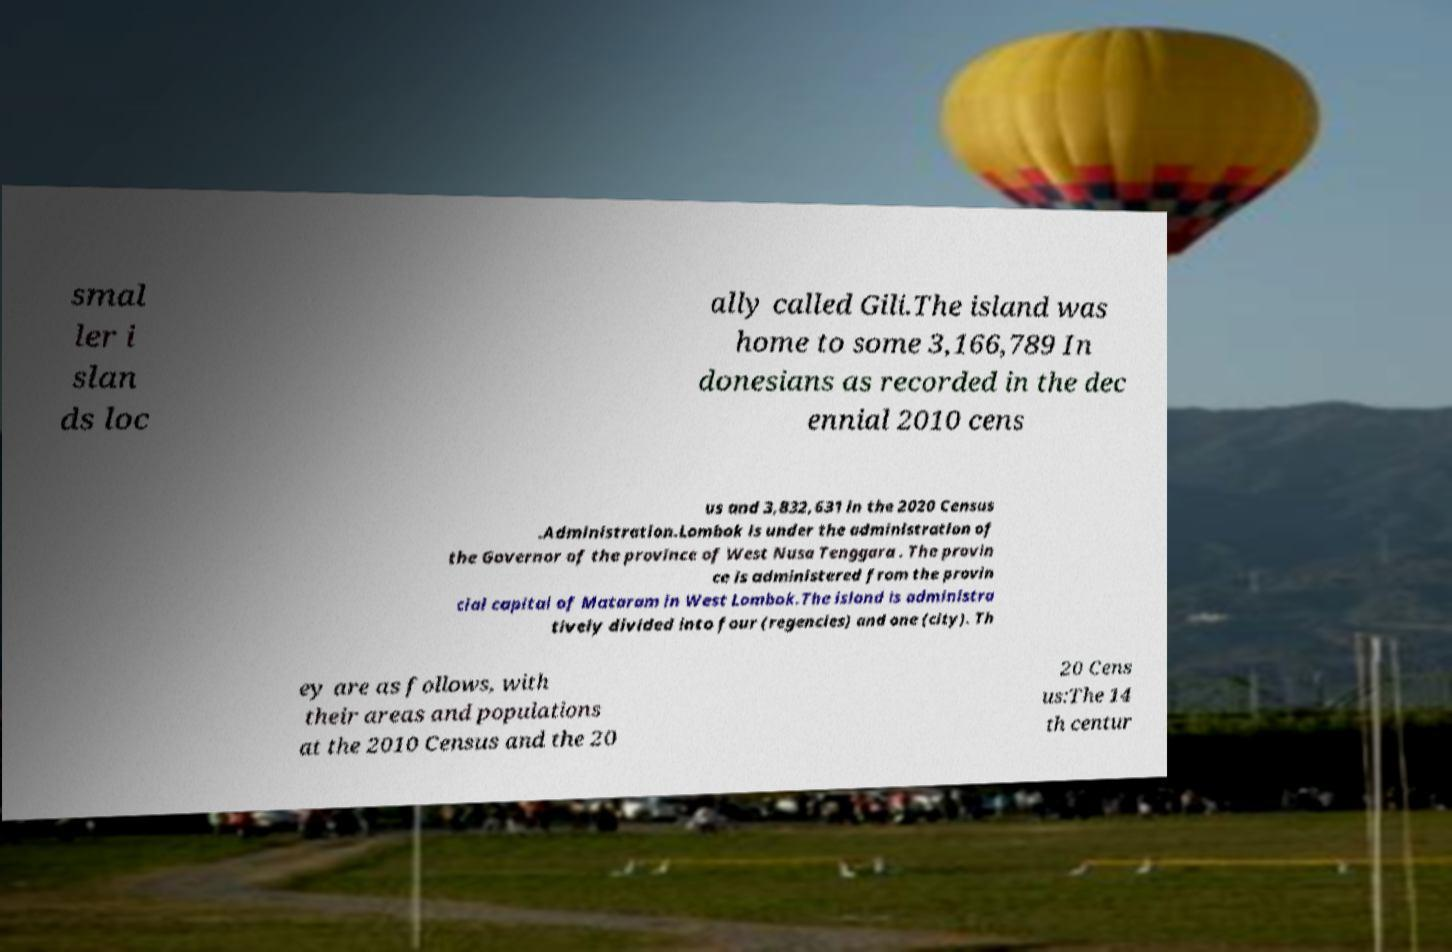There's text embedded in this image that I need extracted. Can you transcribe it verbatim? smal ler i slan ds loc ally called Gili.The island was home to some 3,166,789 In donesians as recorded in the dec ennial 2010 cens us and 3,832,631 in the 2020 Census .Administration.Lombok is under the administration of the Governor of the province of West Nusa Tenggara . The provin ce is administered from the provin cial capital of Mataram in West Lombok.The island is administra tively divided into four (regencies) and one (city). Th ey are as follows, with their areas and populations at the 2010 Census and the 20 20 Cens us:The 14 th centur 